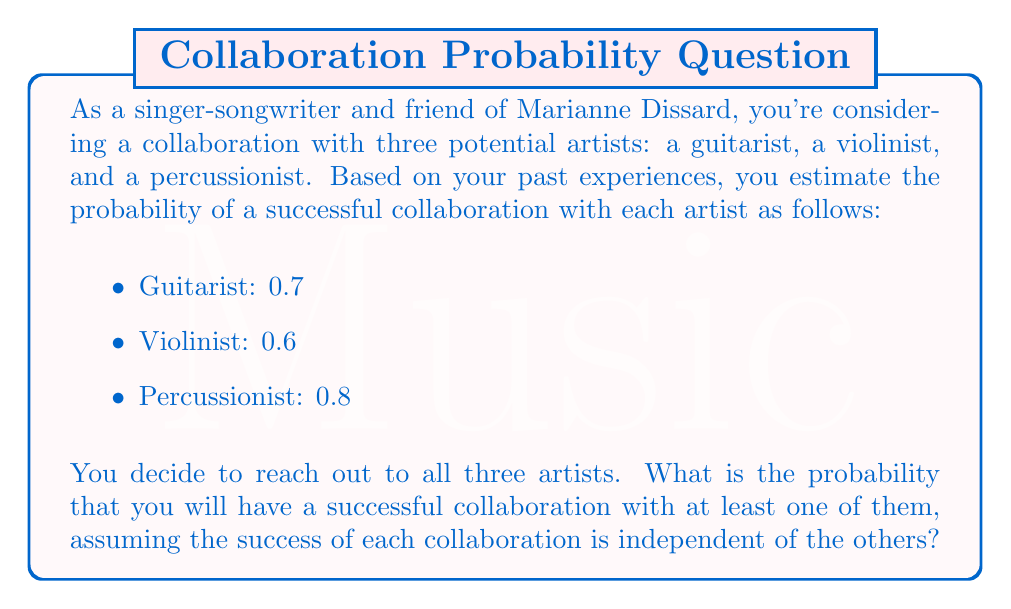Can you answer this question? To solve this problem, we can use the concept of probability of at least one event occurring, which is the complement of the probability that none of the events occur.

Let's define the events:
$G$: Successful collaboration with the guitarist
$V$: Successful collaboration with the violinist
$P$: Successful collaboration with the percussionist

We want to find $P(\text{at least one successful collaboration})$.

This is equivalent to $1 - P(\text{no successful collaborations})$.

Since the events are independent, we can multiply the probabilities of each collaboration not being successful:

$$P(\text{no successful collaborations}) = (1-P(G)) \times (1-P(V)) \times (1-P(P))$$

Now, let's substitute the given probabilities:

$$P(\text{no successful collaborations}) = (1-0.7) \times (1-0.6) \times (1-0.8)$$
$$= 0.3 \times 0.4 \times 0.2$$
$$= 0.024$$

Therefore, the probability of at least one successful collaboration is:

$$P(\text{at least one successful collaboration}) = 1 - P(\text{no successful collaborations})$$
$$= 1 - 0.024$$
$$= 0.976$$
Answer: The probability of having a successful collaboration with at least one of the three artists is 0.976 or 97.6%. 